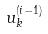<formula> <loc_0><loc_0><loc_500><loc_500>u _ { k } ^ { ( i - 1 ) }</formula> 